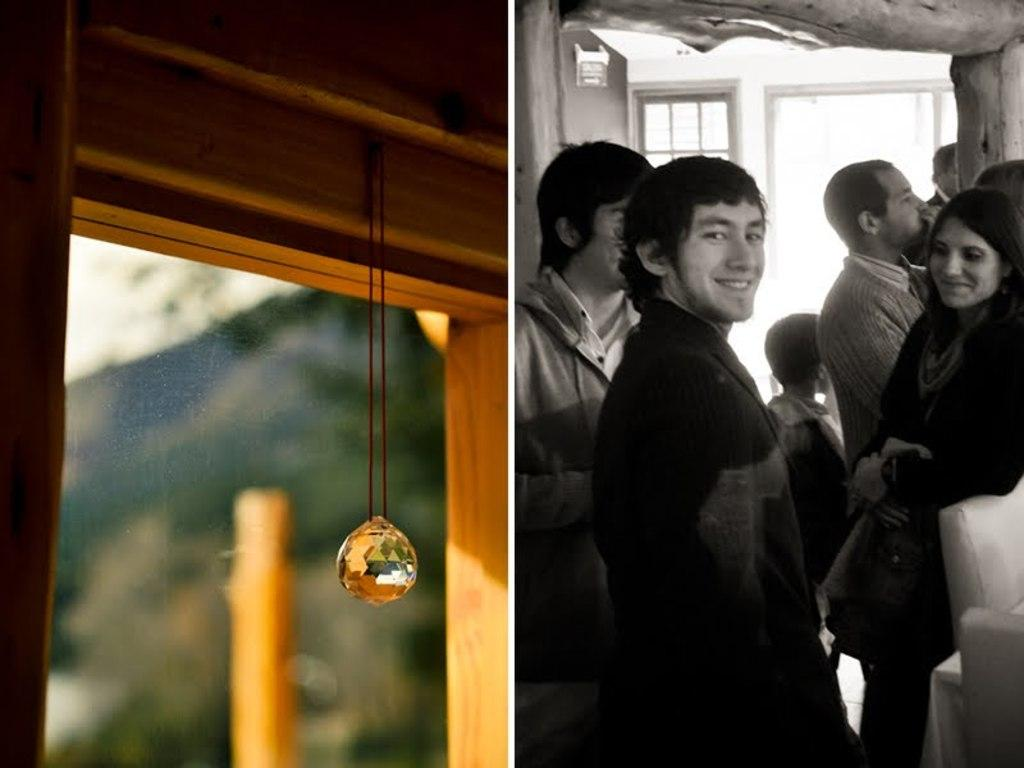What type of image is being described? The image is a collage. Where are the people located in the image? The people are on the right side of the picture. What else can be found on the right side of the picture? There is an object and a window on the right side of the picture. What is present on the left side of the picture? There is a chain and glass on the left side of the picture. What can be seen through the glass on the left side of the picture? The sky is visible through the glass on the left side of the picture. What type of weather can be seen through the arch in the image? There is no arch present in the image, so it is not possible to determine the weather from that perspective. 